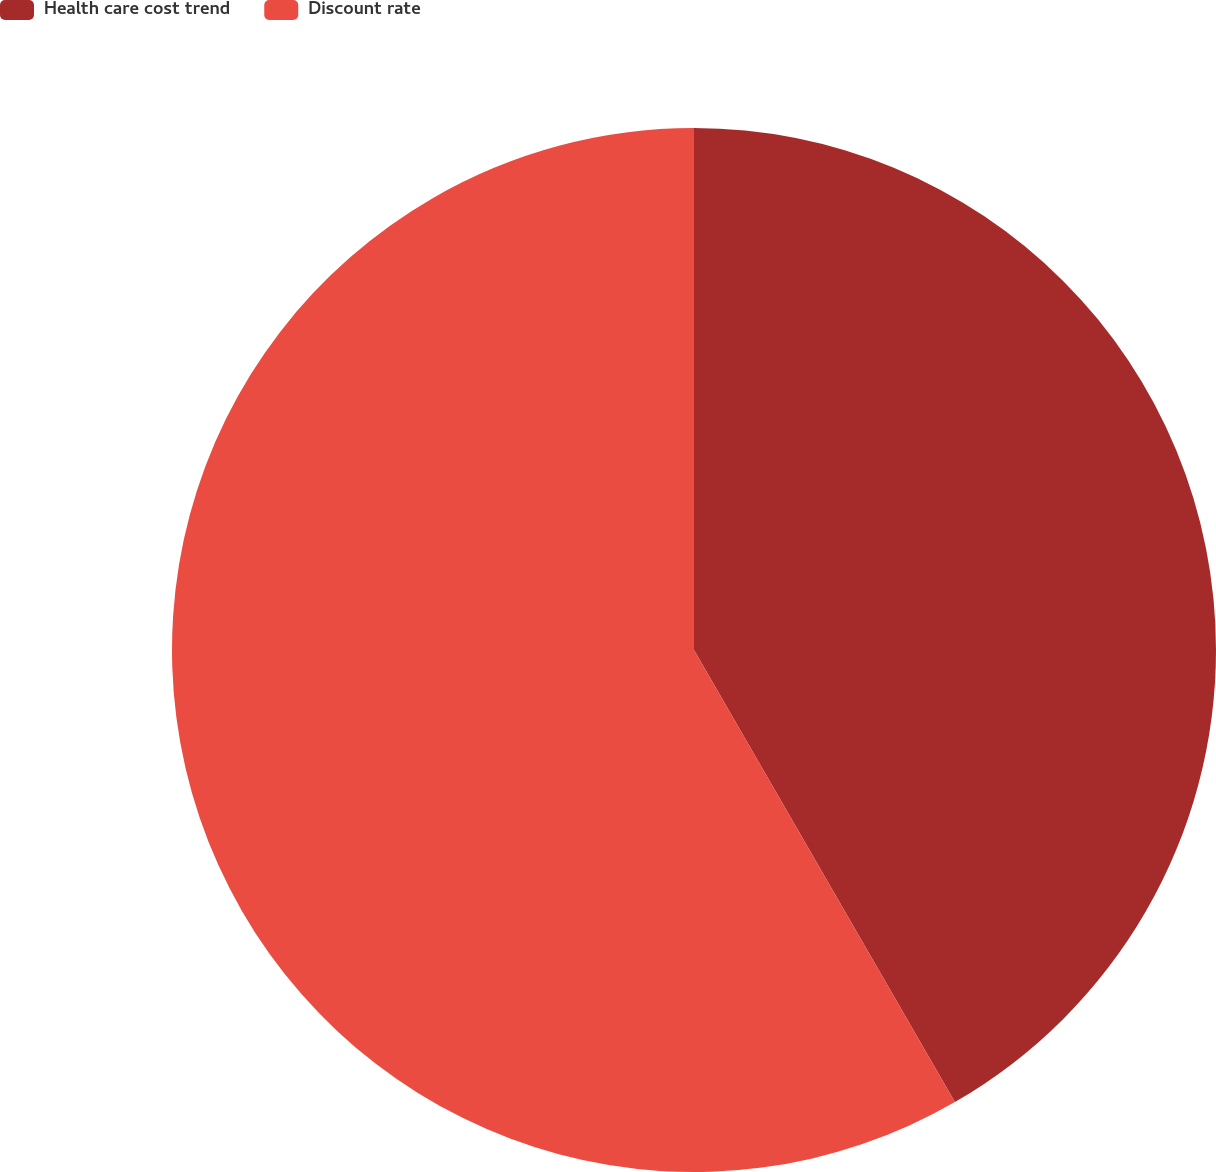Convert chart. <chart><loc_0><loc_0><loc_500><loc_500><pie_chart><fcel>Health care cost trend<fcel>Discount rate<nl><fcel>41.67%<fcel>58.33%<nl></chart> 